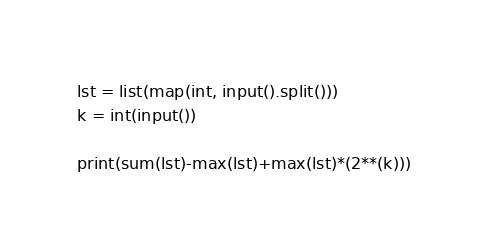<code> <loc_0><loc_0><loc_500><loc_500><_Python_>lst = list(map(int, input().split()))
k = int(input())

print(sum(lst)-max(lst)+max(lst)*(2**(k)))</code> 